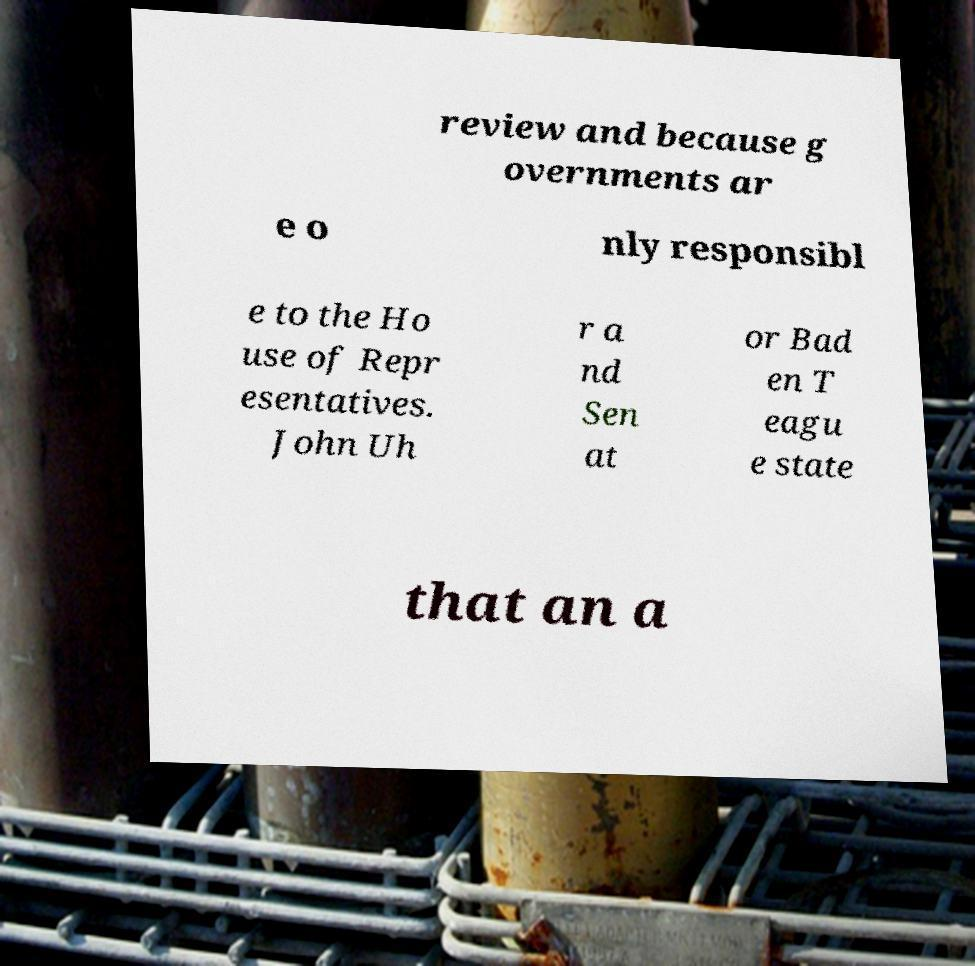Can you read and provide the text displayed in the image?This photo seems to have some interesting text. Can you extract and type it out for me? review and because g overnments ar e o nly responsibl e to the Ho use of Repr esentatives. John Uh r a nd Sen at or Bad en T eagu e state that an a 